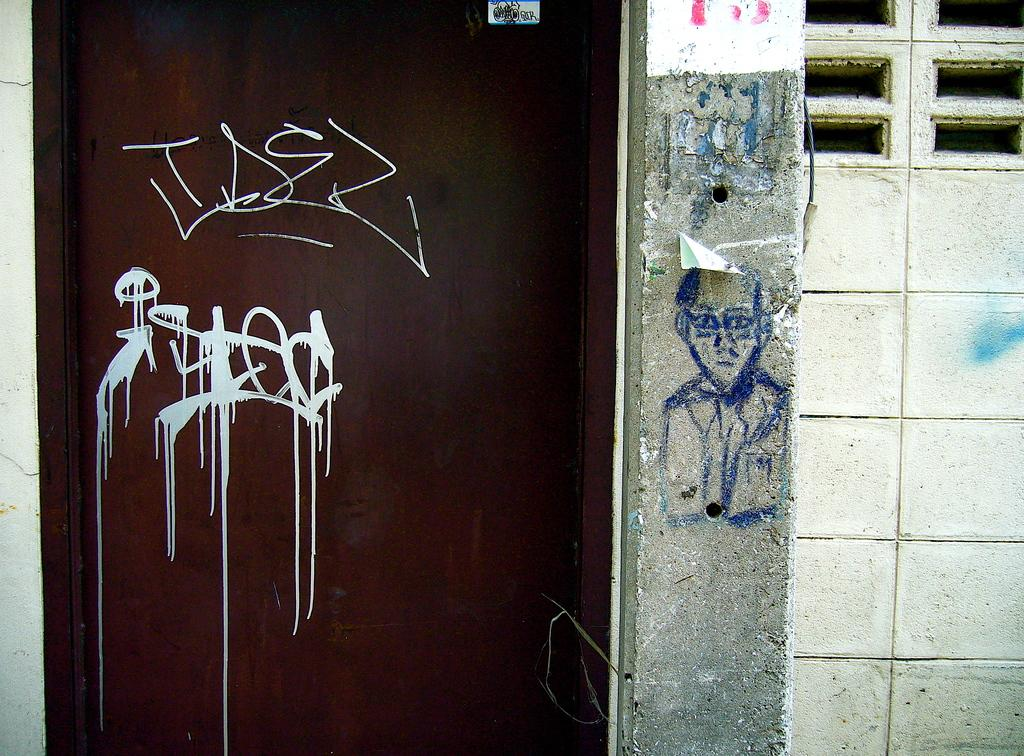What is the main object in the image? There is a door in the image. What can be seen on the door? The door has a drawing on it. What else is present in the image besides the door? There is a wall in the image. What is depicted on the wall? There is a drawing of a person on the wall. What type of cloth is being used for learning in the image? There is no cloth or learning activity present in the image. How many snakes can be seen in the image? There are no snakes present in the image. 